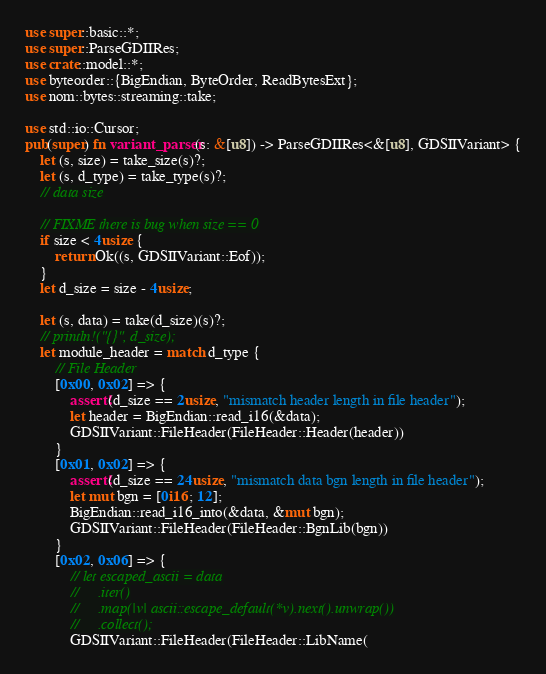<code> <loc_0><loc_0><loc_500><loc_500><_Rust_>use super::basic::*;
use super::ParseGDIIRes;
use crate::model::*;
use byteorder::{BigEndian, ByteOrder, ReadBytesExt};
use nom::bytes::streaming::take;

use std::io::Cursor;
pub(super) fn variant_parser(s: &[u8]) -> ParseGDIIRes<&[u8], GDSIIVariant> {
    let (s, size) = take_size(s)?;
    let (s, d_type) = take_type(s)?;
    // data size

    // FIXME there is bug when size == 0
    if size < 4usize {
        return Ok((s, GDSIIVariant::Eof));
    }
    let d_size = size - 4usize;

    let (s, data) = take(d_size)(s)?;
    // println!("{}", d_size);
    let module_header = match d_type {
        // File Header
        [0x00, 0x02] => {
            assert!(d_size == 2usize, "mismatch header length in file header");
            let header = BigEndian::read_i16(&data);
            GDSIIVariant::FileHeader(FileHeader::Header(header))
        }
        [0x01, 0x02] => {
            assert!(d_size == 24usize, "mismatch data bgn length in file header");
            let mut bgn = [0i16; 12];
            BigEndian::read_i16_into(&data, &mut bgn);
            GDSIIVariant::FileHeader(FileHeader::BgnLib(bgn))
        }
        [0x02, 0x06] => {
            // let escaped_ascii = data
            //     .iter()
            //     .map(|v| ascii::escape_default(*v).next().unwrap())
            //     .collect();
            GDSIIVariant::FileHeader(FileHeader::LibName(</code> 